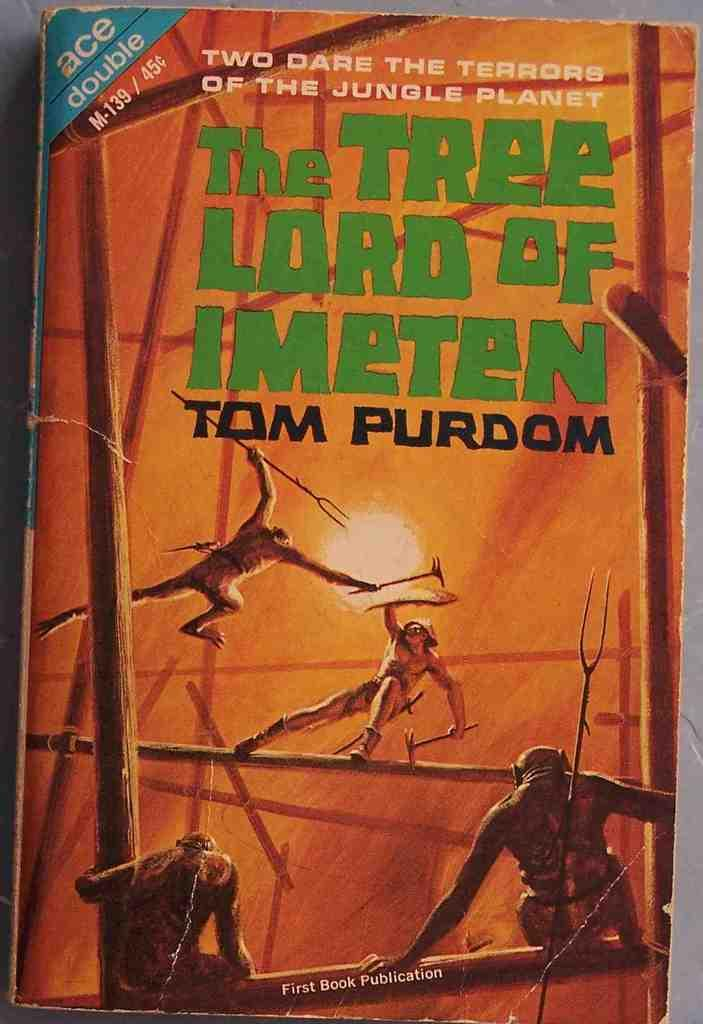<image>
Share a concise interpretation of the image provided. The book's title is The Tree Lord Of Imeten 